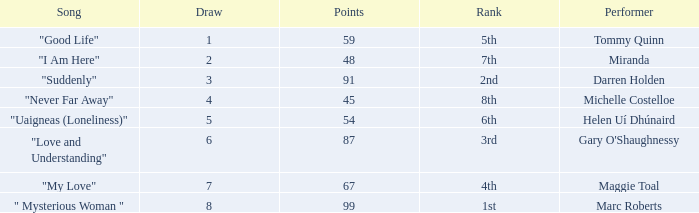What is the average number of points for a song ranked 2nd with a draw greater than 3? None. 